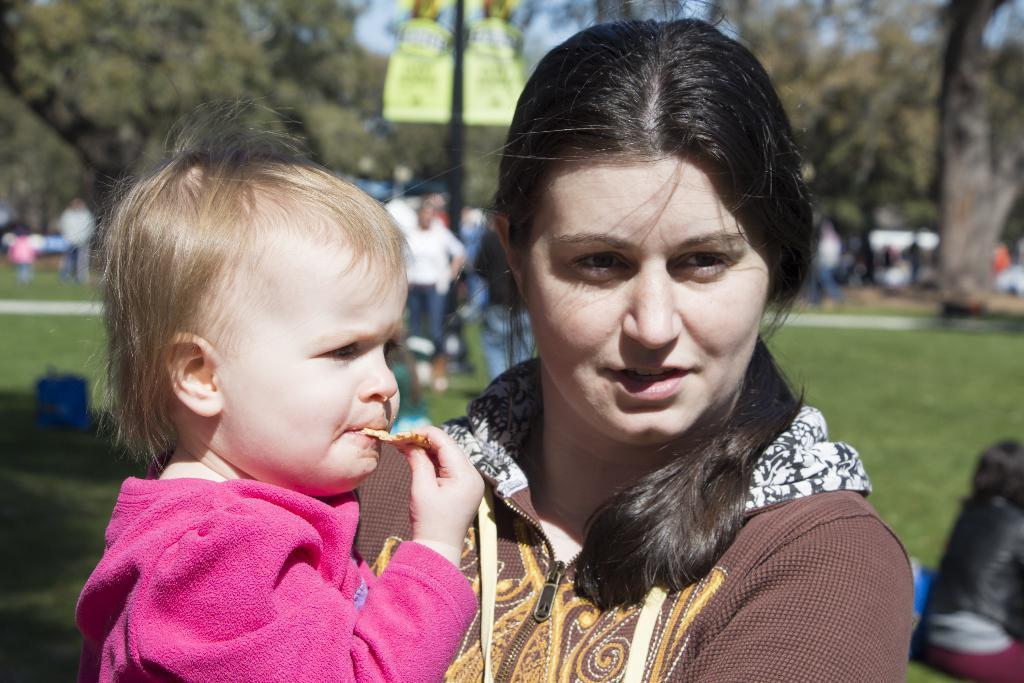Describe this image in one or two sentences. This image consists of a woman holding a kid. The kid is wearing a pink jacket. In the background, there are many trees and many people. At the bottom, there is green grass. 